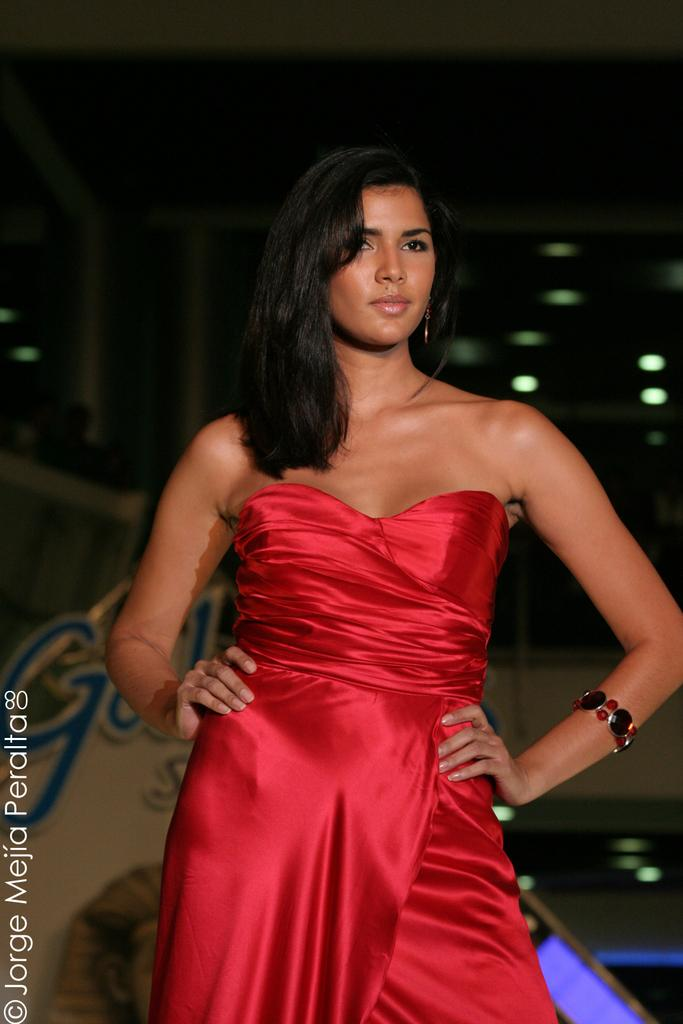Who is the main subject in the image? There is a woman in the image. Can you describe the woman's hair in the image? The woman has long hair. What is the woman wearing in the image? The woman is wearing a red dress. What type of honey is the woman holding in the image? There is no honey present in the image; the woman is wearing a red dress and has long hair. 